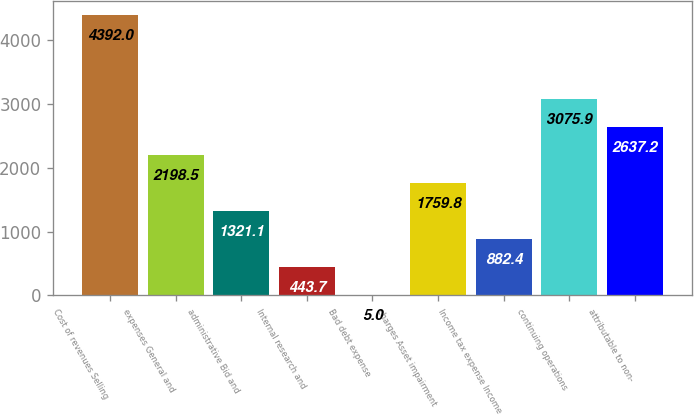Convert chart. <chart><loc_0><loc_0><loc_500><loc_500><bar_chart><fcel>Cost of revenues Selling<fcel>expenses General and<fcel>administrative Bid and<fcel>Internal research and<fcel>Bad debt expense<fcel>charges Asset impairment<fcel>Income tax expense Income<fcel>continuing operations<fcel>attributable to non-<nl><fcel>4392<fcel>2198.5<fcel>1321.1<fcel>443.7<fcel>5<fcel>1759.8<fcel>882.4<fcel>3075.9<fcel>2637.2<nl></chart> 